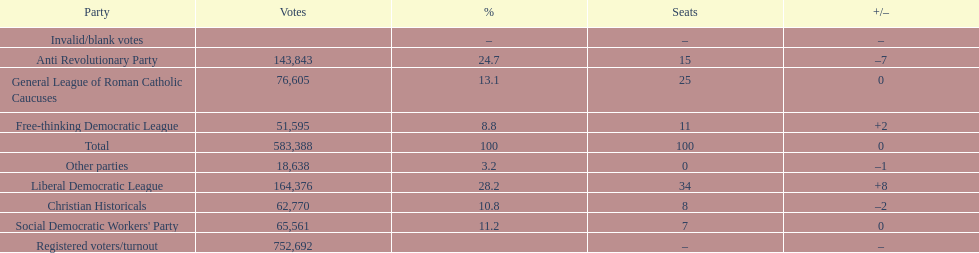How many more votes did the liberal democratic league win over the free-thinking democratic league? 112,781. 